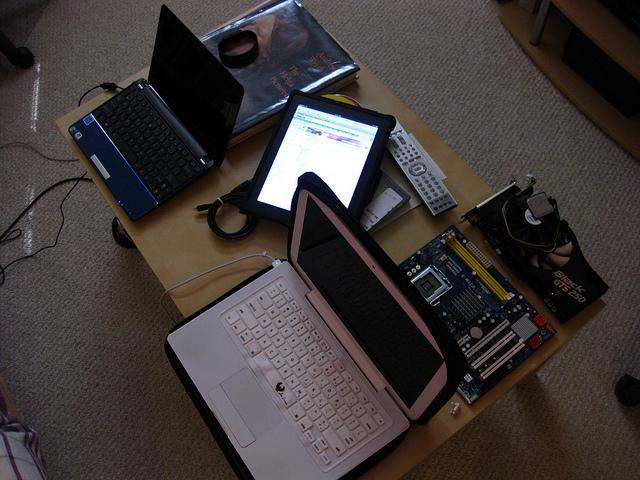How many remotes are there?
Give a very brief answer. 1. How many computers do you see?
Give a very brief answer. 2. How many laptops are visible?
Give a very brief answer. 2. How many people are wearing glasses?
Give a very brief answer. 0. 